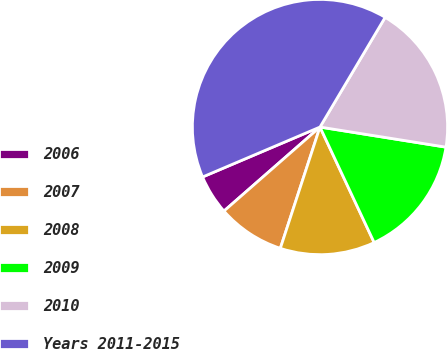Convert chart to OTSL. <chart><loc_0><loc_0><loc_500><loc_500><pie_chart><fcel>2006<fcel>2007<fcel>2008<fcel>2009<fcel>2010<fcel>Years 2011-2015<nl><fcel>5.04%<fcel>8.53%<fcel>12.01%<fcel>15.5%<fcel>18.99%<fcel>39.93%<nl></chart> 